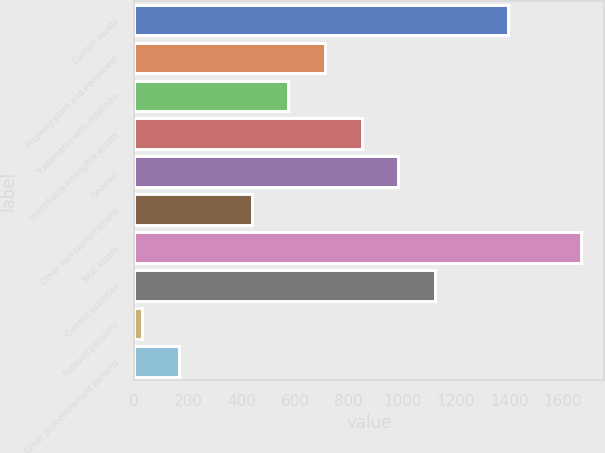<chart> <loc_0><loc_0><loc_500><loc_500><bar_chart><fcel>Current assets<fcel>Property plant and equipment<fcel>Trademarks with indefinite<fcel>Identifiable intangible assets<fcel>Goodwill<fcel>Other non-current assets<fcel>Total assets<fcel>Current liabilities<fcel>Accrued pensions<fcel>Other post-retirement benefits<nl><fcel>1395<fcel>712<fcel>575.4<fcel>848.6<fcel>985.2<fcel>438.8<fcel>1668.2<fcel>1121.8<fcel>29<fcel>165.6<nl></chart> 